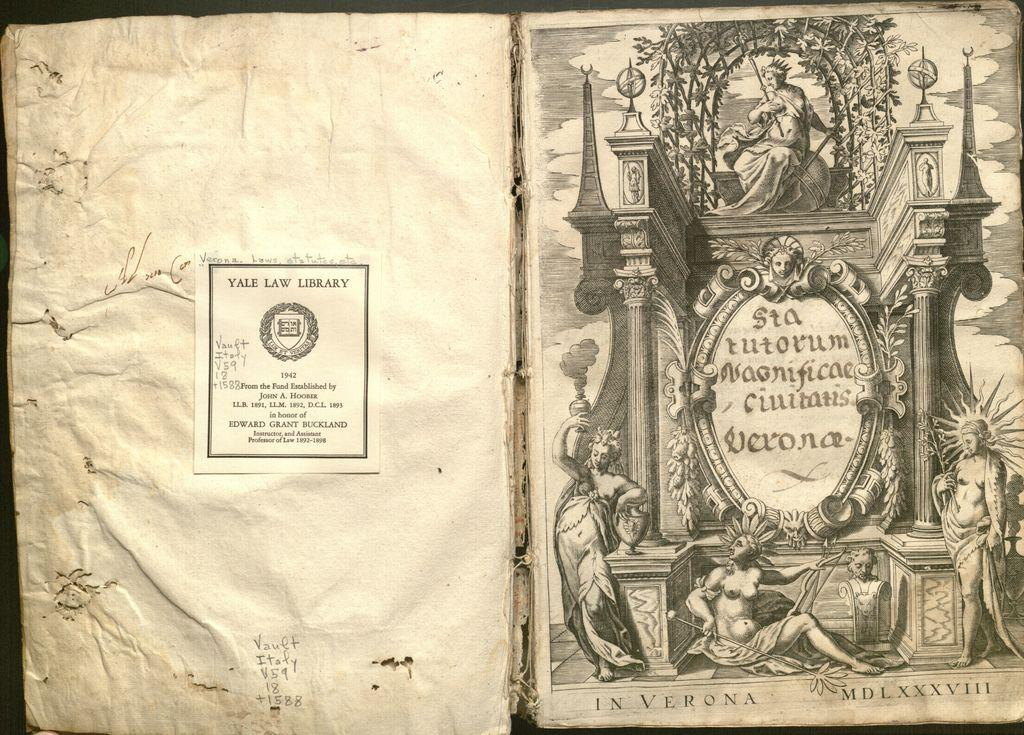<image>
Share a concise interpretation of the image provided. An antique book has a label inside that says it is from the Yale Law Library. 